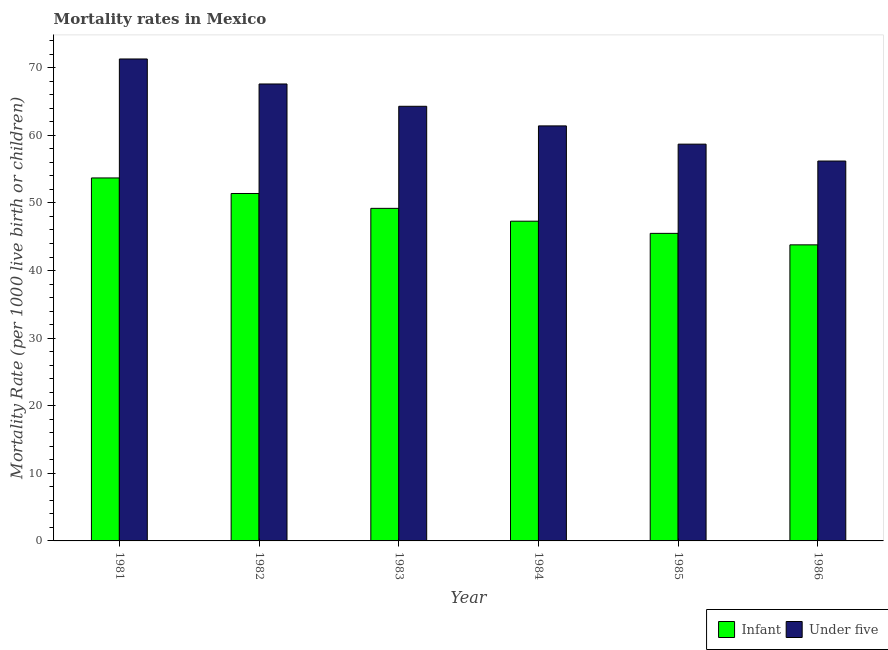Are the number of bars per tick equal to the number of legend labels?
Your answer should be compact. Yes. Are the number of bars on each tick of the X-axis equal?
Provide a short and direct response. Yes. How many bars are there on the 5th tick from the left?
Offer a very short reply. 2. How many bars are there on the 3rd tick from the right?
Offer a very short reply. 2. What is the label of the 4th group of bars from the left?
Ensure brevity in your answer.  1984. What is the under-5 mortality rate in 1985?
Ensure brevity in your answer.  58.7. Across all years, what is the maximum infant mortality rate?
Provide a succinct answer. 53.7. Across all years, what is the minimum under-5 mortality rate?
Keep it short and to the point. 56.2. In which year was the infant mortality rate maximum?
Provide a succinct answer. 1981. What is the total under-5 mortality rate in the graph?
Ensure brevity in your answer.  379.5. What is the difference between the under-5 mortality rate in 1983 and that in 1986?
Your response must be concise. 8.1. What is the difference between the under-5 mortality rate in 1986 and the infant mortality rate in 1983?
Offer a terse response. -8.1. What is the average infant mortality rate per year?
Give a very brief answer. 48.48. What is the ratio of the under-5 mortality rate in 1984 to that in 1986?
Provide a short and direct response. 1.09. Is the difference between the infant mortality rate in 1983 and 1984 greater than the difference between the under-5 mortality rate in 1983 and 1984?
Provide a short and direct response. No. What is the difference between the highest and the second highest infant mortality rate?
Make the answer very short. 2.3. What is the difference between the highest and the lowest under-5 mortality rate?
Provide a short and direct response. 15.1. In how many years, is the infant mortality rate greater than the average infant mortality rate taken over all years?
Offer a very short reply. 3. What does the 1st bar from the left in 1981 represents?
Offer a very short reply. Infant. What does the 1st bar from the right in 1986 represents?
Make the answer very short. Under five. Are all the bars in the graph horizontal?
Your answer should be very brief. No. What is the difference between two consecutive major ticks on the Y-axis?
Make the answer very short. 10. Are the values on the major ticks of Y-axis written in scientific E-notation?
Your response must be concise. No. What is the title of the graph?
Give a very brief answer. Mortality rates in Mexico. What is the label or title of the Y-axis?
Your response must be concise. Mortality Rate (per 1000 live birth or children). What is the Mortality Rate (per 1000 live birth or children) of Infant in 1981?
Your answer should be very brief. 53.7. What is the Mortality Rate (per 1000 live birth or children) in Under five in 1981?
Your answer should be compact. 71.3. What is the Mortality Rate (per 1000 live birth or children) of Infant in 1982?
Keep it short and to the point. 51.4. What is the Mortality Rate (per 1000 live birth or children) in Under five in 1982?
Give a very brief answer. 67.6. What is the Mortality Rate (per 1000 live birth or children) in Infant in 1983?
Give a very brief answer. 49.2. What is the Mortality Rate (per 1000 live birth or children) of Under five in 1983?
Provide a short and direct response. 64.3. What is the Mortality Rate (per 1000 live birth or children) in Infant in 1984?
Your response must be concise. 47.3. What is the Mortality Rate (per 1000 live birth or children) in Under five in 1984?
Offer a terse response. 61.4. What is the Mortality Rate (per 1000 live birth or children) in Infant in 1985?
Your answer should be compact. 45.5. What is the Mortality Rate (per 1000 live birth or children) in Under five in 1985?
Give a very brief answer. 58.7. What is the Mortality Rate (per 1000 live birth or children) in Infant in 1986?
Ensure brevity in your answer.  43.8. What is the Mortality Rate (per 1000 live birth or children) of Under five in 1986?
Your answer should be very brief. 56.2. Across all years, what is the maximum Mortality Rate (per 1000 live birth or children) of Infant?
Keep it short and to the point. 53.7. Across all years, what is the maximum Mortality Rate (per 1000 live birth or children) of Under five?
Keep it short and to the point. 71.3. Across all years, what is the minimum Mortality Rate (per 1000 live birth or children) of Infant?
Make the answer very short. 43.8. Across all years, what is the minimum Mortality Rate (per 1000 live birth or children) of Under five?
Ensure brevity in your answer.  56.2. What is the total Mortality Rate (per 1000 live birth or children) of Infant in the graph?
Provide a succinct answer. 290.9. What is the total Mortality Rate (per 1000 live birth or children) of Under five in the graph?
Give a very brief answer. 379.5. What is the difference between the Mortality Rate (per 1000 live birth or children) of Under five in 1981 and that in 1982?
Provide a short and direct response. 3.7. What is the difference between the Mortality Rate (per 1000 live birth or children) in Infant in 1981 and that in 1983?
Your answer should be compact. 4.5. What is the difference between the Mortality Rate (per 1000 live birth or children) of Under five in 1981 and that in 1983?
Your response must be concise. 7. What is the difference between the Mortality Rate (per 1000 live birth or children) of Under five in 1981 and that in 1984?
Give a very brief answer. 9.9. What is the difference between the Mortality Rate (per 1000 live birth or children) in Under five in 1981 and that in 1985?
Provide a succinct answer. 12.6. What is the difference between the Mortality Rate (per 1000 live birth or children) of Infant in 1981 and that in 1986?
Give a very brief answer. 9.9. What is the difference between the Mortality Rate (per 1000 live birth or children) of Under five in 1981 and that in 1986?
Offer a terse response. 15.1. What is the difference between the Mortality Rate (per 1000 live birth or children) in Infant in 1982 and that in 1983?
Your response must be concise. 2.2. What is the difference between the Mortality Rate (per 1000 live birth or children) in Under five in 1982 and that in 1983?
Offer a terse response. 3.3. What is the difference between the Mortality Rate (per 1000 live birth or children) of Infant in 1982 and that in 1984?
Ensure brevity in your answer.  4.1. What is the difference between the Mortality Rate (per 1000 live birth or children) in Under five in 1982 and that in 1984?
Provide a short and direct response. 6.2. What is the difference between the Mortality Rate (per 1000 live birth or children) of Under five in 1982 and that in 1985?
Offer a terse response. 8.9. What is the difference between the Mortality Rate (per 1000 live birth or children) of Infant in 1983 and that in 1984?
Give a very brief answer. 1.9. What is the difference between the Mortality Rate (per 1000 live birth or children) of Under five in 1983 and that in 1985?
Offer a terse response. 5.6. What is the difference between the Mortality Rate (per 1000 live birth or children) of Under five in 1983 and that in 1986?
Your answer should be compact. 8.1. What is the difference between the Mortality Rate (per 1000 live birth or children) of Under five in 1984 and that in 1985?
Your answer should be compact. 2.7. What is the difference between the Mortality Rate (per 1000 live birth or children) of Infant in 1985 and that in 1986?
Keep it short and to the point. 1.7. What is the difference between the Mortality Rate (per 1000 live birth or children) in Under five in 1985 and that in 1986?
Keep it short and to the point. 2.5. What is the difference between the Mortality Rate (per 1000 live birth or children) in Infant in 1981 and the Mortality Rate (per 1000 live birth or children) in Under five in 1982?
Your response must be concise. -13.9. What is the difference between the Mortality Rate (per 1000 live birth or children) in Infant in 1981 and the Mortality Rate (per 1000 live birth or children) in Under five in 1984?
Provide a succinct answer. -7.7. What is the difference between the Mortality Rate (per 1000 live birth or children) in Infant in 1982 and the Mortality Rate (per 1000 live birth or children) in Under five in 1984?
Provide a succinct answer. -10. What is the difference between the Mortality Rate (per 1000 live birth or children) in Infant in 1983 and the Mortality Rate (per 1000 live birth or children) in Under five in 1985?
Give a very brief answer. -9.5. What is the difference between the Mortality Rate (per 1000 live birth or children) of Infant in 1985 and the Mortality Rate (per 1000 live birth or children) of Under five in 1986?
Keep it short and to the point. -10.7. What is the average Mortality Rate (per 1000 live birth or children) in Infant per year?
Ensure brevity in your answer.  48.48. What is the average Mortality Rate (per 1000 live birth or children) of Under five per year?
Ensure brevity in your answer.  63.25. In the year 1981, what is the difference between the Mortality Rate (per 1000 live birth or children) in Infant and Mortality Rate (per 1000 live birth or children) in Under five?
Make the answer very short. -17.6. In the year 1982, what is the difference between the Mortality Rate (per 1000 live birth or children) in Infant and Mortality Rate (per 1000 live birth or children) in Under five?
Make the answer very short. -16.2. In the year 1983, what is the difference between the Mortality Rate (per 1000 live birth or children) of Infant and Mortality Rate (per 1000 live birth or children) of Under five?
Your response must be concise. -15.1. In the year 1984, what is the difference between the Mortality Rate (per 1000 live birth or children) in Infant and Mortality Rate (per 1000 live birth or children) in Under five?
Make the answer very short. -14.1. What is the ratio of the Mortality Rate (per 1000 live birth or children) of Infant in 1981 to that in 1982?
Give a very brief answer. 1.04. What is the ratio of the Mortality Rate (per 1000 live birth or children) in Under five in 1981 to that in 1982?
Offer a terse response. 1.05. What is the ratio of the Mortality Rate (per 1000 live birth or children) in Infant in 1981 to that in 1983?
Offer a terse response. 1.09. What is the ratio of the Mortality Rate (per 1000 live birth or children) in Under five in 1981 to that in 1983?
Provide a short and direct response. 1.11. What is the ratio of the Mortality Rate (per 1000 live birth or children) of Infant in 1981 to that in 1984?
Offer a very short reply. 1.14. What is the ratio of the Mortality Rate (per 1000 live birth or children) in Under five in 1981 to that in 1984?
Offer a very short reply. 1.16. What is the ratio of the Mortality Rate (per 1000 live birth or children) in Infant in 1981 to that in 1985?
Your answer should be very brief. 1.18. What is the ratio of the Mortality Rate (per 1000 live birth or children) in Under five in 1981 to that in 1985?
Give a very brief answer. 1.21. What is the ratio of the Mortality Rate (per 1000 live birth or children) in Infant in 1981 to that in 1986?
Your answer should be very brief. 1.23. What is the ratio of the Mortality Rate (per 1000 live birth or children) of Under five in 1981 to that in 1986?
Your answer should be compact. 1.27. What is the ratio of the Mortality Rate (per 1000 live birth or children) in Infant in 1982 to that in 1983?
Your answer should be compact. 1.04. What is the ratio of the Mortality Rate (per 1000 live birth or children) of Under five in 1982 to that in 1983?
Your answer should be compact. 1.05. What is the ratio of the Mortality Rate (per 1000 live birth or children) of Infant in 1982 to that in 1984?
Provide a succinct answer. 1.09. What is the ratio of the Mortality Rate (per 1000 live birth or children) of Under five in 1982 to that in 1984?
Your answer should be compact. 1.1. What is the ratio of the Mortality Rate (per 1000 live birth or children) of Infant in 1982 to that in 1985?
Make the answer very short. 1.13. What is the ratio of the Mortality Rate (per 1000 live birth or children) of Under five in 1982 to that in 1985?
Make the answer very short. 1.15. What is the ratio of the Mortality Rate (per 1000 live birth or children) in Infant in 1982 to that in 1986?
Give a very brief answer. 1.17. What is the ratio of the Mortality Rate (per 1000 live birth or children) in Under five in 1982 to that in 1986?
Your response must be concise. 1.2. What is the ratio of the Mortality Rate (per 1000 live birth or children) of Infant in 1983 to that in 1984?
Provide a succinct answer. 1.04. What is the ratio of the Mortality Rate (per 1000 live birth or children) of Under five in 1983 to that in 1984?
Your response must be concise. 1.05. What is the ratio of the Mortality Rate (per 1000 live birth or children) of Infant in 1983 to that in 1985?
Provide a succinct answer. 1.08. What is the ratio of the Mortality Rate (per 1000 live birth or children) in Under five in 1983 to that in 1985?
Make the answer very short. 1.1. What is the ratio of the Mortality Rate (per 1000 live birth or children) in Infant in 1983 to that in 1986?
Provide a short and direct response. 1.12. What is the ratio of the Mortality Rate (per 1000 live birth or children) of Under five in 1983 to that in 1986?
Give a very brief answer. 1.14. What is the ratio of the Mortality Rate (per 1000 live birth or children) in Infant in 1984 to that in 1985?
Offer a terse response. 1.04. What is the ratio of the Mortality Rate (per 1000 live birth or children) in Under five in 1984 to that in 1985?
Make the answer very short. 1.05. What is the ratio of the Mortality Rate (per 1000 live birth or children) of Infant in 1984 to that in 1986?
Keep it short and to the point. 1.08. What is the ratio of the Mortality Rate (per 1000 live birth or children) of Under five in 1984 to that in 1986?
Provide a succinct answer. 1.09. What is the ratio of the Mortality Rate (per 1000 live birth or children) of Infant in 1985 to that in 1986?
Your response must be concise. 1.04. What is the ratio of the Mortality Rate (per 1000 live birth or children) of Under five in 1985 to that in 1986?
Your answer should be very brief. 1.04. What is the difference between the highest and the second highest Mortality Rate (per 1000 live birth or children) in Infant?
Your answer should be compact. 2.3. What is the difference between the highest and the second highest Mortality Rate (per 1000 live birth or children) in Under five?
Provide a short and direct response. 3.7. What is the difference between the highest and the lowest Mortality Rate (per 1000 live birth or children) in Infant?
Keep it short and to the point. 9.9. 